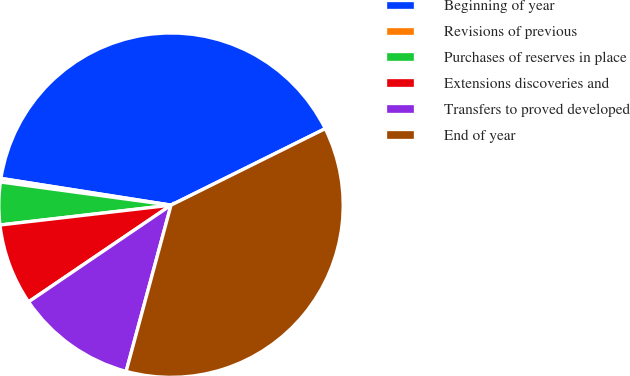<chart> <loc_0><loc_0><loc_500><loc_500><pie_chart><fcel>Beginning of year<fcel>Revisions of previous<fcel>Purchases of reserves in place<fcel>Extensions discoveries and<fcel>Transfers to proved developed<fcel>End of year<nl><fcel>40.18%<fcel>0.33%<fcel>3.99%<fcel>7.65%<fcel>11.31%<fcel>36.52%<nl></chart> 